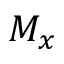<formula> <loc_0><loc_0><loc_500><loc_500>M _ { x }</formula> 